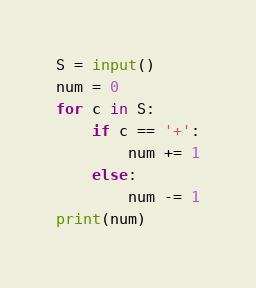<code> <loc_0><loc_0><loc_500><loc_500><_Python_>S = input()
num = 0
for c in S:
    if c == '+':
        num += 1
    else:
        num -= 1
print(num)
</code> 